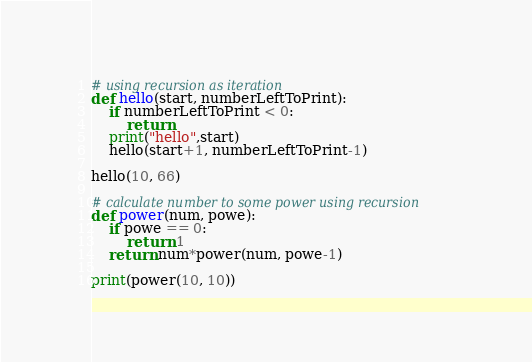<code> <loc_0><loc_0><loc_500><loc_500><_Python_># using recursion as iteration
def hello(start, numberLeftToPrint):
    if numberLeftToPrint < 0:
        return
    print("hello",start)
    hello(start+1, numberLeftToPrint-1)

hello(10, 66)

# calculate number to some power using recursion
def power(num, powe):
    if powe == 0:
        return 1
    return num*power(num, powe-1)

print(power(10, 10))</code> 